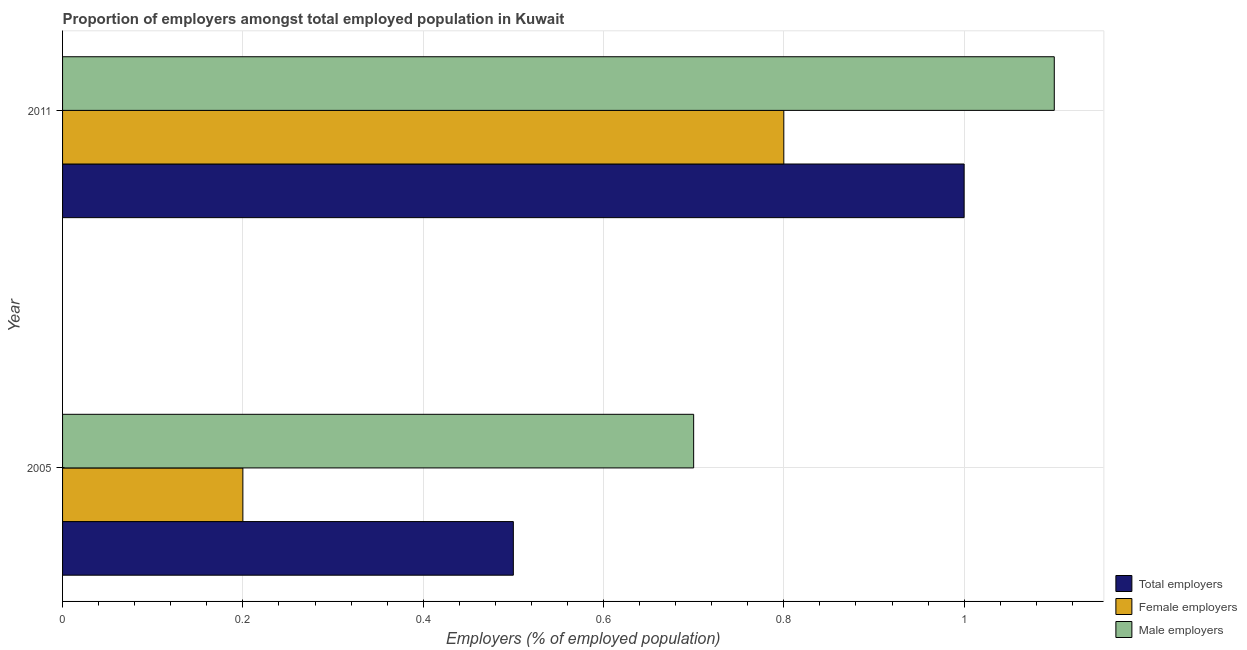How many bars are there on the 2nd tick from the top?
Provide a succinct answer. 3. What is the label of the 1st group of bars from the top?
Provide a short and direct response. 2011. What is the percentage of male employers in 2011?
Your answer should be compact. 1.1. Across all years, what is the maximum percentage of male employers?
Your response must be concise. 1.1. Across all years, what is the minimum percentage of total employers?
Your answer should be very brief. 0.5. In which year was the percentage of female employers maximum?
Give a very brief answer. 2011. What is the total percentage of female employers in the graph?
Give a very brief answer. 1. What is the difference between the percentage of total employers in 2005 and that in 2011?
Your answer should be very brief. -0.5. What is the difference between the percentage of total employers in 2011 and the percentage of female employers in 2005?
Your answer should be compact. 0.8. In the year 2011, what is the difference between the percentage of total employers and percentage of male employers?
Ensure brevity in your answer.  -0.1. In how many years, is the percentage of female employers greater than 0.6000000000000001 %?
Offer a very short reply. 1. What is the ratio of the percentage of female employers in 2005 to that in 2011?
Give a very brief answer. 0.25. What does the 2nd bar from the top in 2005 represents?
Provide a short and direct response. Female employers. What does the 1st bar from the bottom in 2005 represents?
Make the answer very short. Total employers. Does the graph contain any zero values?
Your answer should be compact. No. Does the graph contain grids?
Keep it short and to the point. Yes. Where does the legend appear in the graph?
Your answer should be compact. Bottom right. What is the title of the graph?
Offer a terse response. Proportion of employers amongst total employed population in Kuwait. What is the label or title of the X-axis?
Ensure brevity in your answer.  Employers (% of employed population). What is the label or title of the Y-axis?
Offer a terse response. Year. What is the Employers (% of employed population) in Female employers in 2005?
Provide a short and direct response. 0.2. What is the Employers (% of employed population) in Male employers in 2005?
Ensure brevity in your answer.  0.7. What is the Employers (% of employed population) of Female employers in 2011?
Offer a terse response. 0.8. What is the Employers (% of employed population) in Male employers in 2011?
Your response must be concise. 1.1. Across all years, what is the maximum Employers (% of employed population) of Total employers?
Ensure brevity in your answer.  1. Across all years, what is the maximum Employers (% of employed population) in Female employers?
Give a very brief answer. 0.8. Across all years, what is the maximum Employers (% of employed population) in Male employers?
Offer a very short reply. 1.1. Across all years, what is the minimum Employers (% of employed population) of Total employers?
Your answer should be very brief. 0.5. Across all years, what is the minimum Employers (% of employed population) of Female employers?
Provide a succinct answer. 0.2. Across all years, what is the minimum Employers (% of employed population) of Male employers?
Offer a terse response. 0.7. What is the total Employers (% of employed population) in Total employers in the graph?
Offer a terse response. 1.5. What is the total Employers (% of employed population) in Male employers in the graph?
Keep it short and to the point. 1.8. What is the difference between the Employers (% of employed population) of Female employers in 2005 and that in 2011?
Your answer should be compact. -0.6. What is the difference between the Employers (% of employed population) of Male employers in 2005 and that in 2011?
Your response must be concise. -0.4. In the year 2005, what is the difference between the Employers (% of employed population) in Total employers and Employers (% of employed population) in Female employers?
Offer a very short reply. 0.3. In the year 2011, what is the difference between the Employers (% of employed population) in Total employers and Employers (% of employed population) in Female employers?
Offer a terse response. 0.2. What is the ratio of the Employers (% of employed population) in Male employers in 2005 to that in 2011?
Your response must be concise. 0.64. What is the difference between the highest and the second highest Employers (% of employed population) in Total employers?
Provide a short and direct response. 0.5. What is the difference between the highest and the second highest Employers (% of employed population) of Female employers?
Your response must be concise. 0.6. What is the difference between the highest and the lowest Employers (% of employed population) of Total employers?
Make the answer very short. 0.5. 